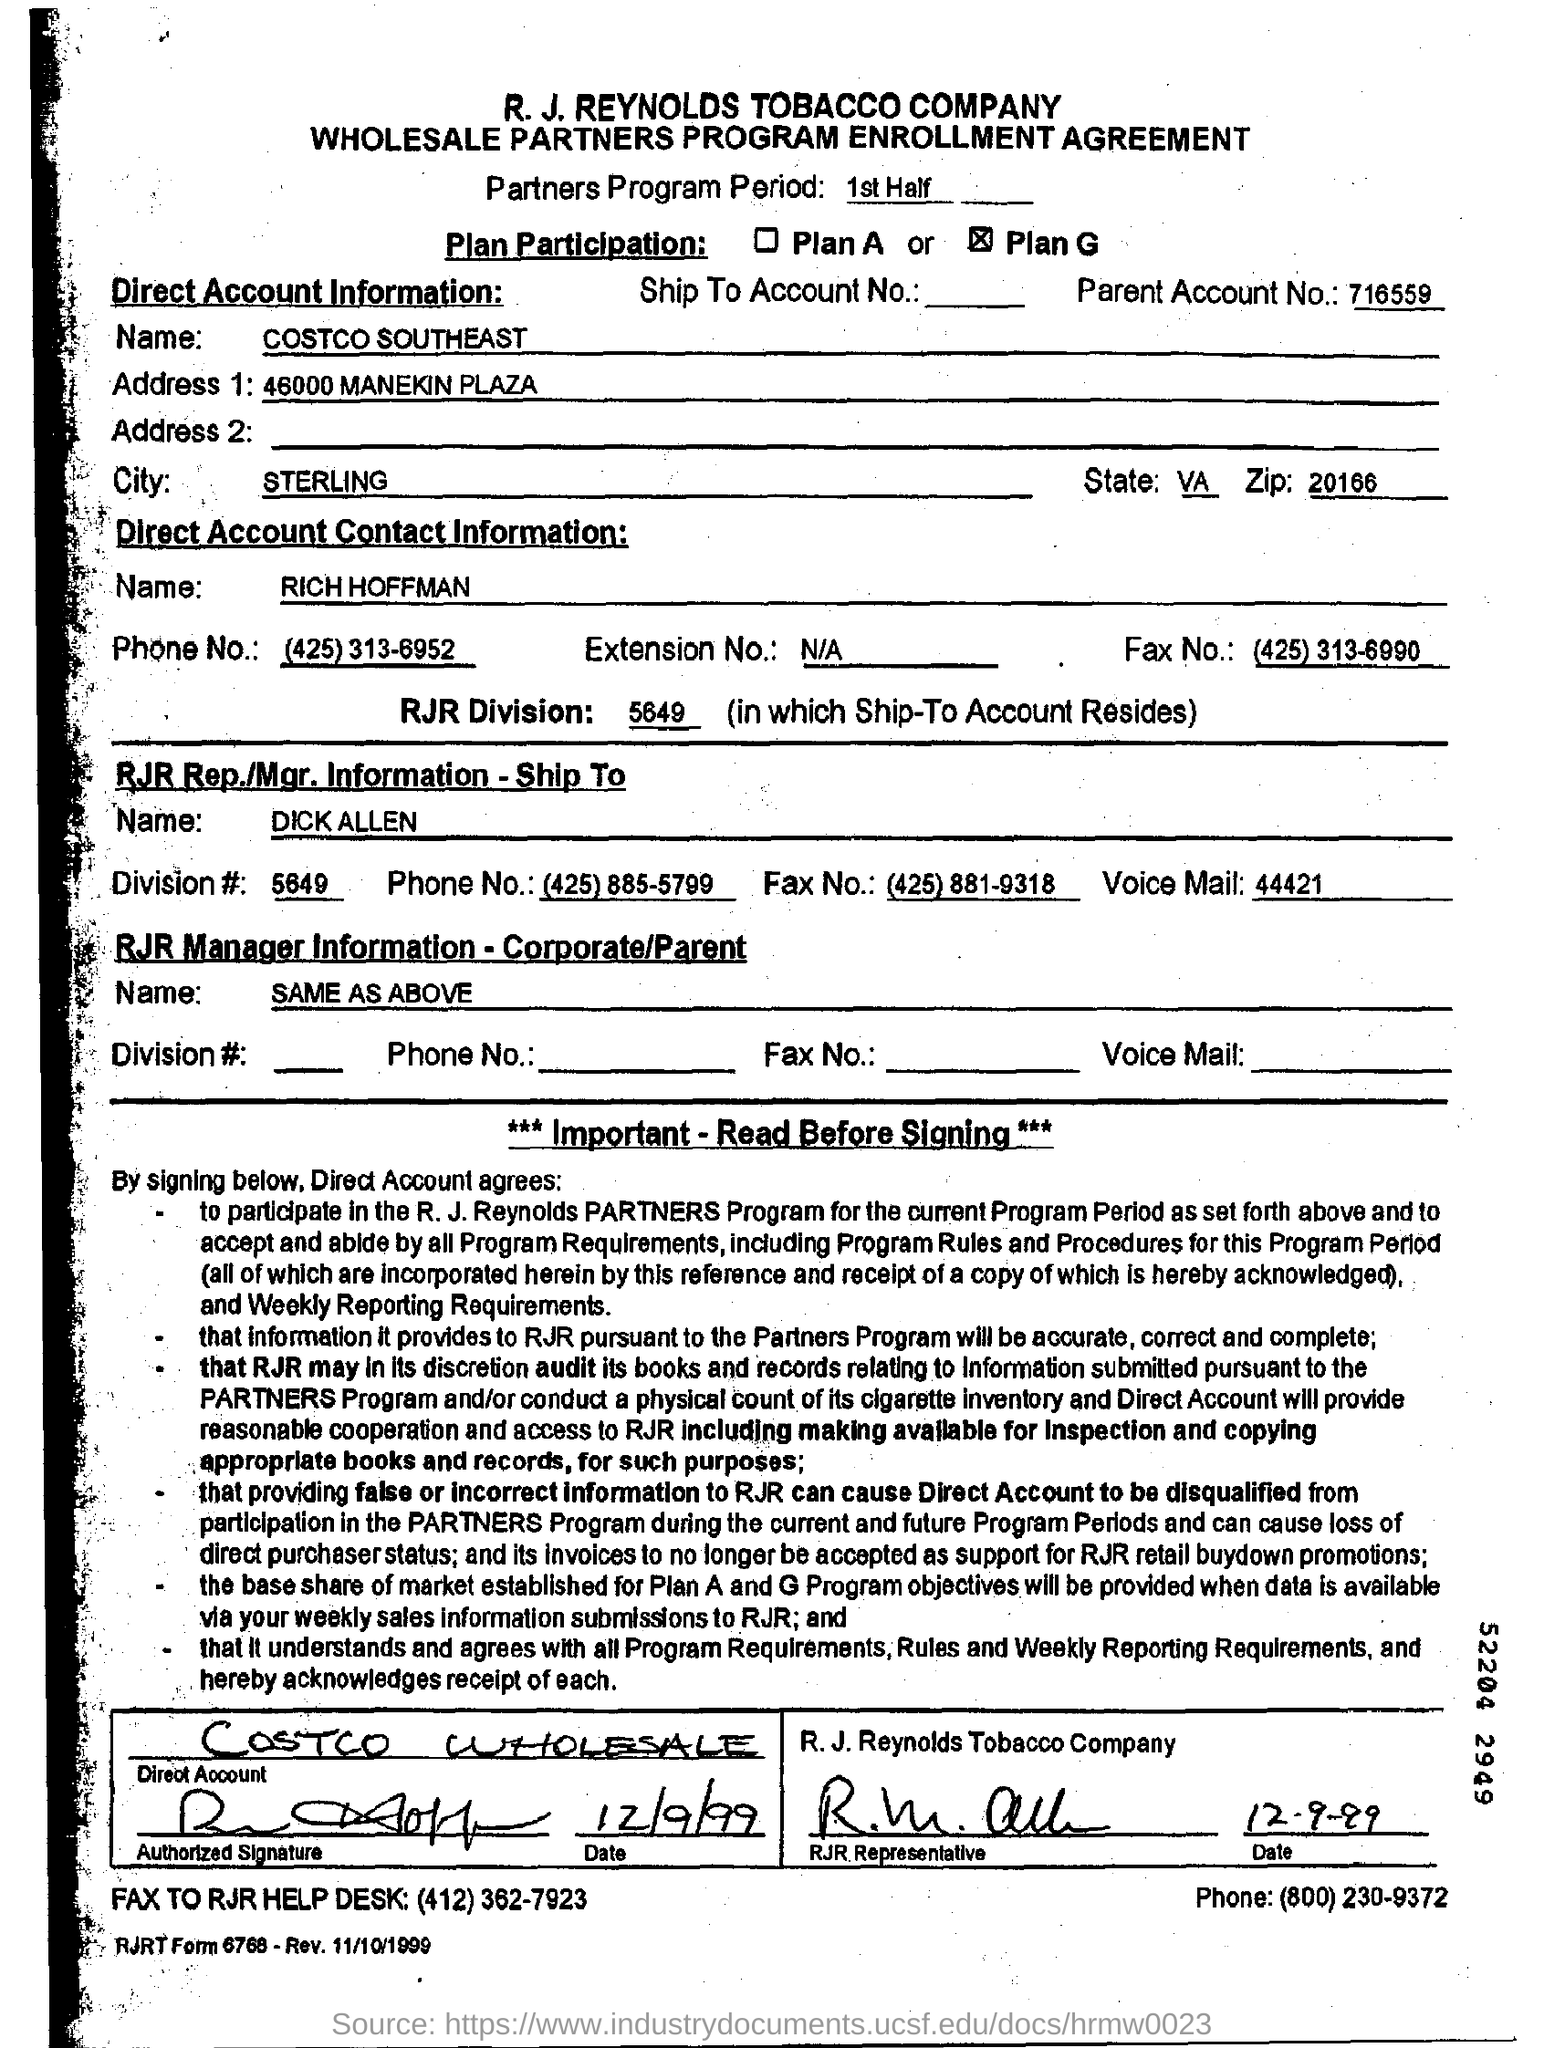What type of agreement is given here?
Your response must be concise. WHOLESALE PARTNERS PROGRAM ENROLLMENT AGREEMENT. What is the Partners Program Period?
Provide a short and direct response. 1st Half. What is the Parent Account No?
Offer a very short reply. 716559. What is the name of Direct Account contact person?
Make the answer very short. RICH HOFFMAN. What is the RJR Division in which Ship-To Account Resides?
Make the answer very short. 5649. Who is the RJR Rep./Mgr. ?
Ensure brevity in your answer.  DICK ALLEN. What is the City name given?
Your response must be concise. STERLING. What is the ZIP Code given?
Offer a terse response. 20166. 